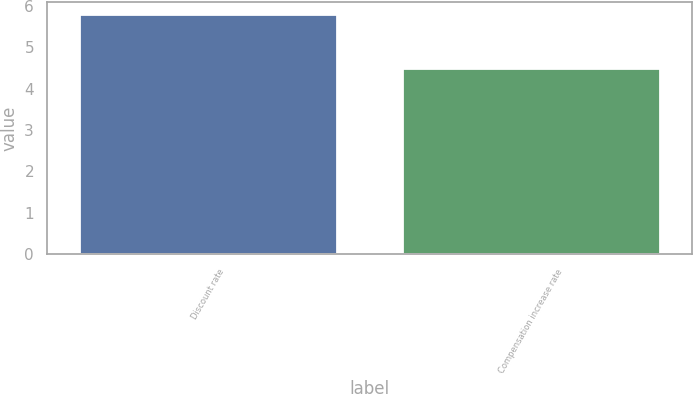Convert chart to OTSL. <chart><loc_0><loc_0><loc_500><loc_500><bar_chart><fcel>Discount rate<fcel>Compensation increase rate<nl><fcel>5.8<fcel>4.5<nl></chart> 